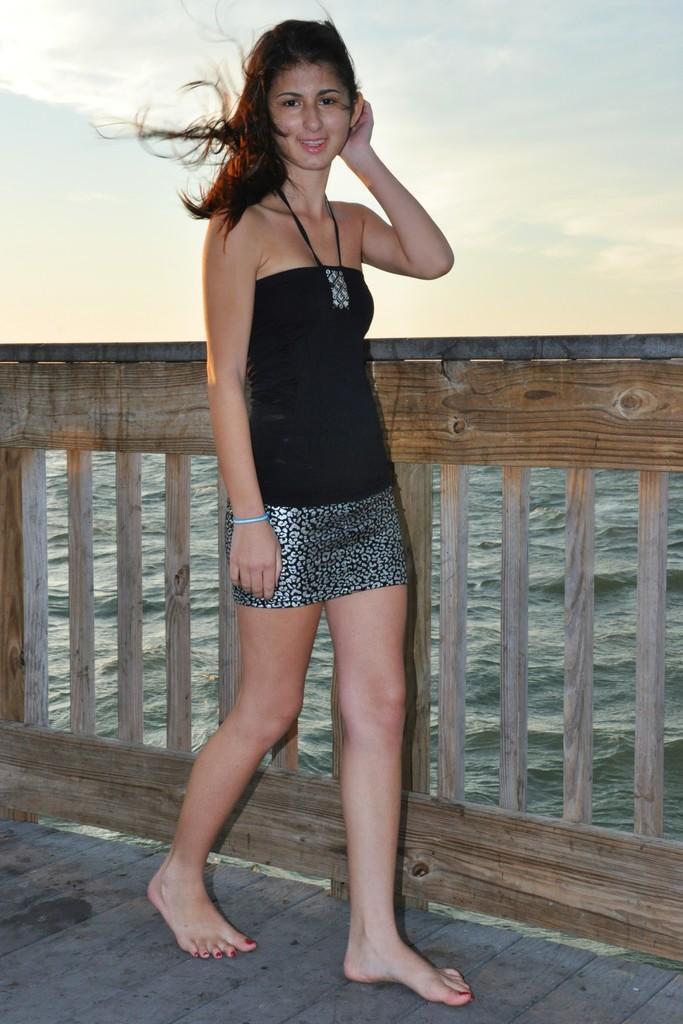Please provide a concise description of this image. In this picture we can see a woman on the ground and in the background we can see a fence, water, sky. 